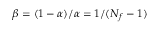Convert formula to latex. <formula><loc_0><loc_0><loc_500><loc_500>\beta = ( 1 - \alpha ) / \alpha = 1 / ( N _ { f } - 1 )</formula> 